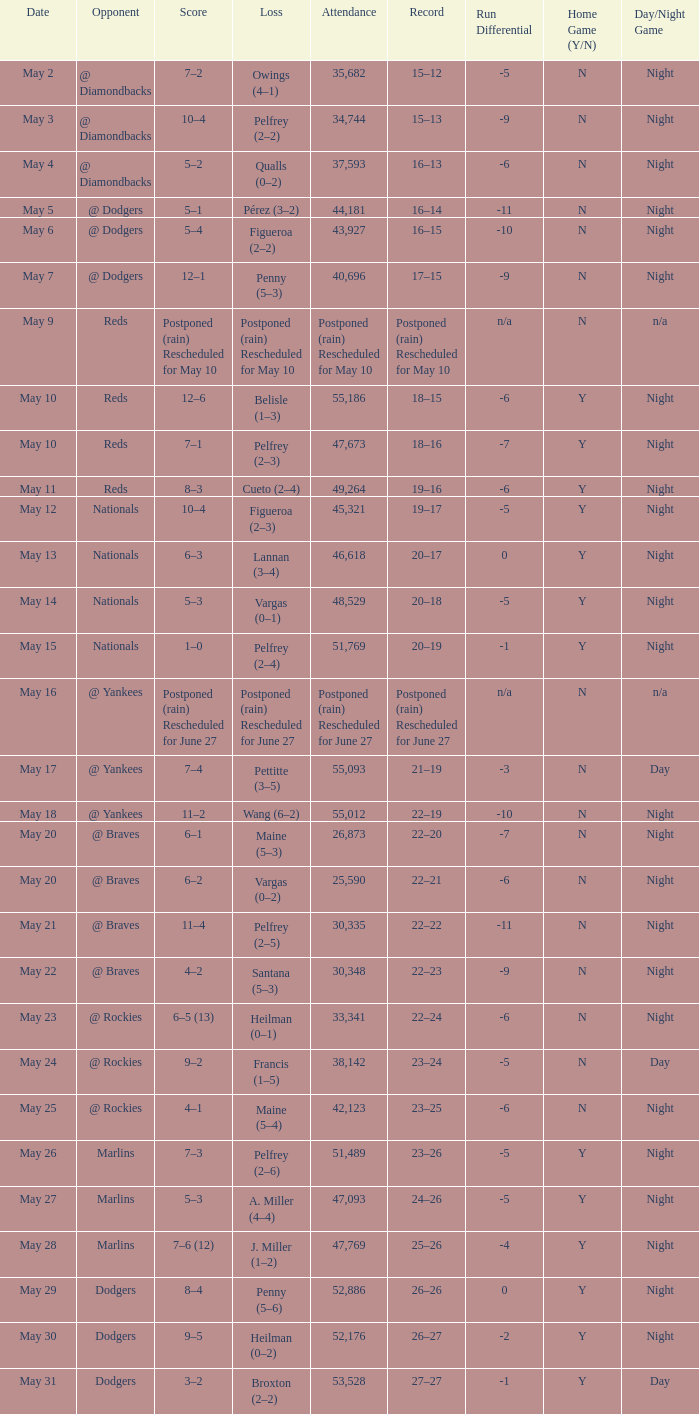Score of postponed (rain) rescheduled for June 27 had what loss? Postponed (rain) Rescheduled for June 27. 